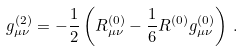<formula> <loc_0><loc_0><loc_500><loc_500>g _ { \mu \nu } ^ { ( 2 ) } = - \frac { 1 } { 2 } \left ( R _ { \mu \nu } ^ { ( 0 ) } - \frac { 1 } { 6 } R ^ { ( 0 ) } g _ { \mu \nu } ^ { ( 0 ) } \right ) \, .</formula> 